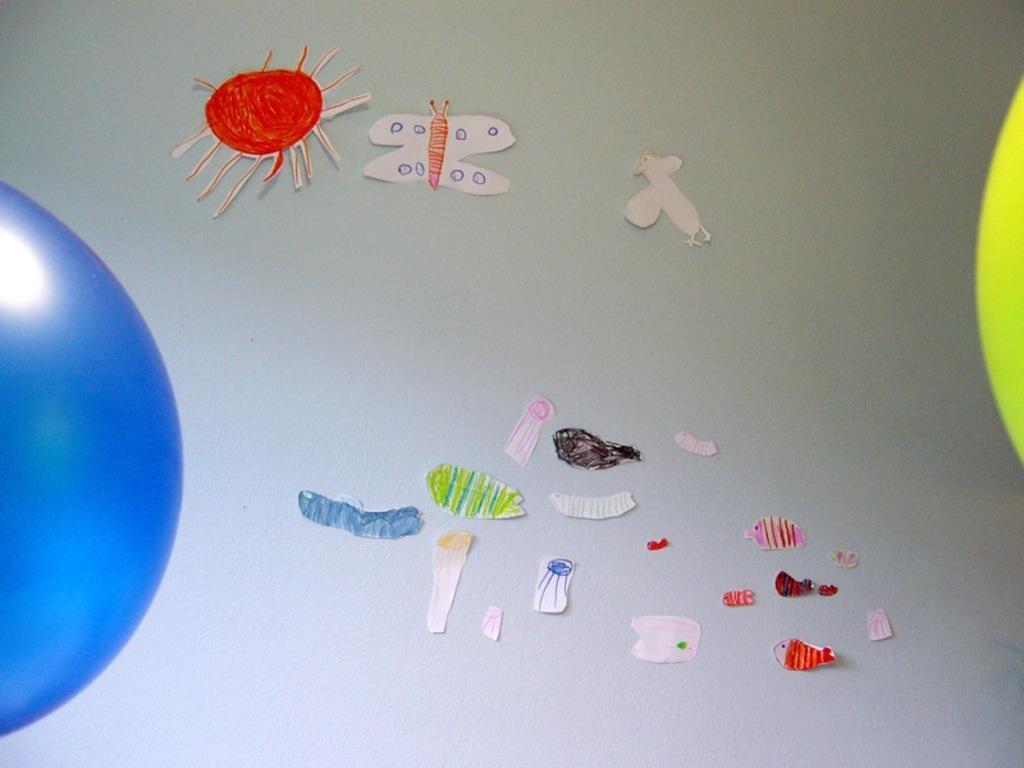Please provide a concise description of this image. In this picture we can see some paper crafts, there is a plane background. 